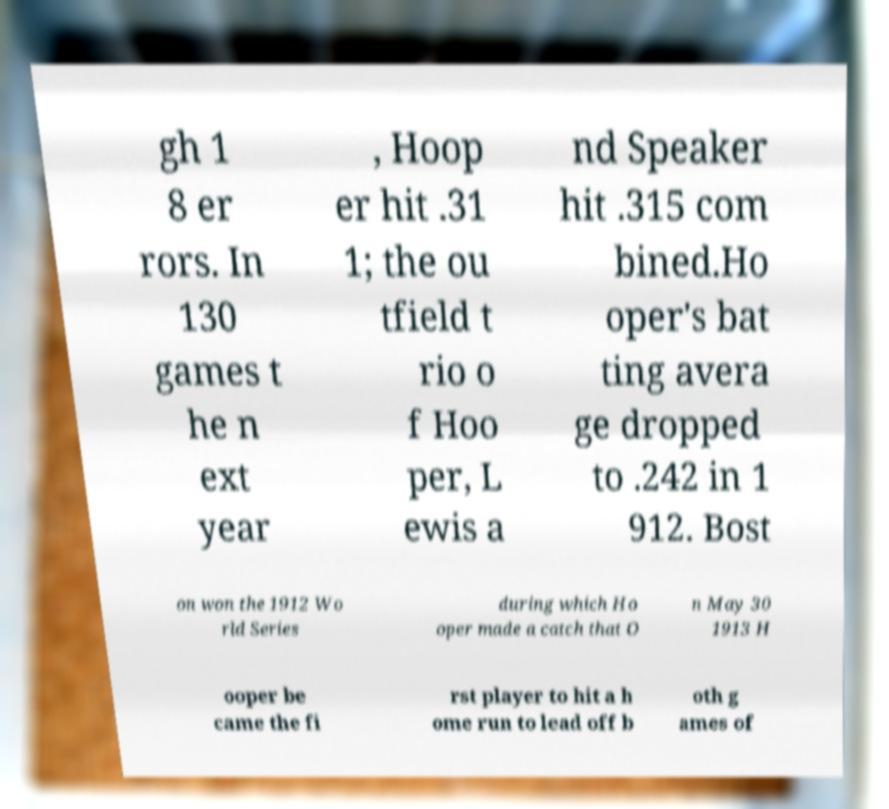What messages or text are displayed in this image? I need them in a readable, typed format. gh 1 8 er rors. In 130 games t he n ext year , Hoop er hit .31 1; the ou tfield t rio o f Hoo per, L ewis a nd Speaker hit .315 com bined.Ho oper's bat ting avera ge dropped to .242 in 1 912. Bost on won the 1912 Wo rld Series during which Ho oper made a catch that O n May 30 1913 H ooper be came the fi rst player to hit a h ome run to lead off b oth g ames of 